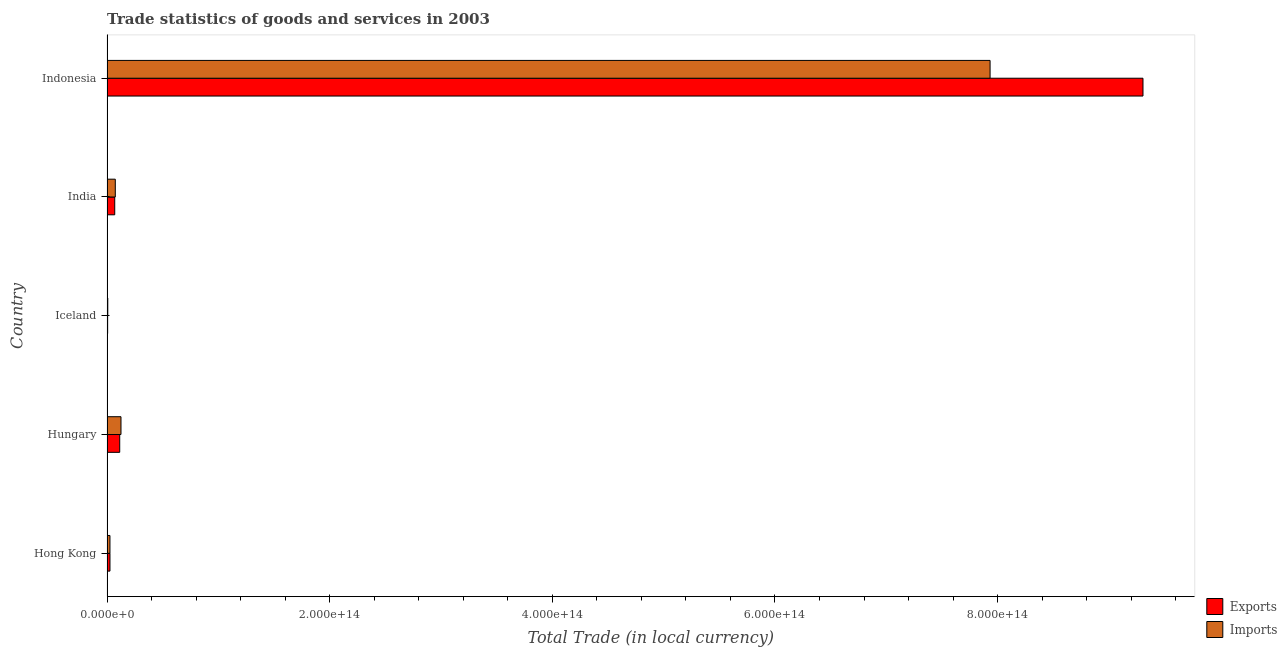How many different coloured bars are there?
Offer a very short reply. 2. Are the number of bars per tick equal to the number of legend labels?
Your response must be concise. Yes. How many bars are there on the 2nd tick from the top?
Ensure brevity in your answer.  2. How many bars are there on the 4th tick from the bottom?
Offer a very short reply. 2. What is the label of the 3rd group of bars from the top?
Provide a succinct answer. Iceland. What is the imports of goods and services in Hong Kong?
Provide a succinct answer. 2.65e+12. Across all countries, what is the maximum export of goods and services?
Offer a terse response. 9.31e+14. Across all countries, what is the minimum export of goods and services?
Offer a very short reply. 5.66e+11. In which country was the imports of goods and services maximum?
Keep it short and to the point. Indonesia. In which country was the export of goods and services minimum?
Offer a very short reply. Iceland. What is the total imports of goods and services in the graph?
Your response must be concise. 8.17e+14. What is the difference between the export of goods and services in Hungary and that in India?
Your response must be concise. 4.48e+12. What is the difference between the imports of goods and services in Hong Kong and the export of goods and services in India?
Provide a succinct answer. -4.29e+12. What is the average imports of goods and services per country?
Offer a terse response. 1.63e+14. What is the difference between the imports of goods and services and export of goods and services in Hong Kong?
Provide a short and direct response. -8.14e+09. In how many countries, is the export of goods and services greater than 40000000000000 LCU?
Keep it short and to the point. 1. What is the ratio of the imports of goods and services in Hungary to that in Iceland?
Give a very brief answer. 18.11. Is the imports of goods and services in Hong Kong less than that in India?
Ensure brevity in your answer.  Yes. Is the difference between the export of goods and services in Hong Kong and Indonesia greater than the difference between the imports of goods and services in Hong Kong and Indonesia?
Make the answer very short. No. What is the difference between the highest and the second highest export of goods and services?
Your response must be concise. 9.19e+14. What is the difference between the highest and the lowest imports of goods and services?
Provide a succinct answer. 7.93e+14. In how many countries, is the imports of goods and services greater than the average imports of goods and services taken over all countries?
Keep it short and to the point. 1. What does the 1st bar from the top in Iceland represents?
Your answer should be compact. Imports. What does the 2nd bar from the bottom in India represents?
Make the answer very short. Imports. How many bars are there?
Your answer should be very brief. 10. Are all the bars in the graph horizontal?
Your answer should be compact. Yes. What is the difference between two consecutive major ticks on the X-axis?
Ensure brevity in your answer.  2.00e+14. Where does the legend appear in the graph?
Make the answer very short. Bottom right. What is the title of the graph?
Ensure brevity in your answer.  Trade statistics of goods and services in 2003. Does "Lowest 20% of population" appear as one of the legend labels in the graph?
Your answer should be compact. No. What is the label or title of the X-axis?
Give a very brief answer. Total Trade (in local currency). What is the Total Trade (in local currency) of Exports in Hong Kong?
Provide a short and direct response. 2.66e+12. What is the Total Trade (in local currency) of Imports in Hong Kong?
Offer a terse response. 2.65e+12. What is the Total Trade (in local currency) of Exports in Hungary?
Provide a succinct answer. 1.14e+13. What is the Total Trade (in local currency) in Imports in Hungary?
Ensure brevity in your answer.  1.26e+13. What is the Total Trade (in local currency) of Exports in Iceland?
Your answer should be very brief. 5.66e+11. What is the Total Trade (in local currency) in Imports in Iceland?
Offer a very short reply. 6.93e+11. What is the Total Trade (in local currency) of Exports in India?
Keep it short and to the point. 6.95e+12. What is the Total Trade (in local currency) of Imports in India?
Make the answer very short. 7.45e+12. What is the Total Trade (in local currency) of Exports in Indonesia?
Your answer should be very brief. 9.31e+14. What is the Total Trade (in local currency) in Imports in Indonesia?
Give a very brief answer. 7.93e+14. Across all countries, what is the maximum Total Trade (in local currency) of Exports?
Offer a terse response. 9.31e+14. Across all countries, what is the maximum Total Trade (in local currency) of Imports?
Make the answer very short. 7.93e+14. Across all countries, what is the minimum Total Trade (in local currency) in Exports?
Offer a terse response. 5.66e+11. Across all countries, what is the minimum Total Trade (in local currency) of Imports?
Your answer should be very brief. 6.93e+11. What is the total Total Trade (in local currency) of Exports in the graph?
Provide a short and direct response. 9.52e+14. What is the total Total Trade (in local currency) in Imports in the graph?
Provide a short and direct response. 8.17e+14. What is the difference between the Total Trade (in local currency) in Exports in Hong Kong and that in Hungary?
Provide a short and direct response. -8.77e+12. What is the difference between the Total Trade (in local currency) of Imports in Hong Kong and that in Hungary?
Offer a very short reply. -9.91e+12. What is the difference between the Total Trade (in local currency) of Exports in Hong Kong and that in Iceland?
Ensure brevity in your answer.  2.09e+12. What is the difference between the Total Trade (in local currency) in Imports in Hong Kong and that in Iceland?
Offer a terse response. 1.96e+12. What is the difference between the Total Trade (in local currency) of Exports in Hong Kong and that in India?
Ensure brevity in your answer.  -4.29e+12. What is the difference between the Total Trade (in local currency) in Imports in Hong Kong and that in India?
Ensure brevity in your answer.  -4.80e+12. What is the difference between the Total Trade (in local currency) in Exports in Hong Kong and that in Indonesia?
Make the answer very short. -9.28e+14. What is the difference between the Total Trade (in local currency) of Imports in Hong Kong and that in Indonesia?
Make the answer very short. -7.91e+14. What is the difference between the Total Trade (in local currency) in Exports in Hungary and that in Iceland?
Offer a very short reply. 1.09e+13. What is the difference between the Total Trade (in local currency) in Imports in Hungary and that in Iceland?
Make the answer very short. 1.19e+13. What is the difference between the Total Trade (in local currency) in Exports in Hungary and that in India?
Ensure brevity in your answer.  4.48e+12. What is the difference between the Total Trade (in local currency) of Imports in Hungary and that in India?
Provide a succinct answer. 5.11e+12. What is the difference between the Total Trade (in local currency) in Exports in Hungary and that in Indonesia?
Your response must be concise. -9.19e+14. What is the difference between the Total Trade (in local currency) in Imports in Hungary and that in Indonesia?
Give a very brief answer. -7.81e+14. What is the difference between the Total Trade (in local currency) in Exports in Iceland and that in India?
Provide a succinct answer. -6.38e+12. What is the difference between the Total Trade (in local currency) in Imports in Iceland and that in India?
Offer a terse response. -6.76e+12. What is the difference between the Total Trade (in local currency) of Exports in Iceland and that in Indonesia?
Give a very brief answer. -9.30e+14. What is the difference between the Total Trade (in local currency) of Imports in Iceland and that in Indonesia?
Your answer should be very brief. -7.93e+14. What is the difference between the Total Trade (in local currency) of Exports in India and that in Indonesia?
Your response must be concise. -9.24e+14. What is the difference between the Total Trade (in local currency) of Imports in India and that in Indonesia?
Offer a very short reply. -7.86e+14. What is the difference between the Total Trade (in local currency) in Exports in Hong Kong and the Total Trade (in local currency) in Imports in Hungary?
Your response must be concise. -9.90e+12. What is the difference between the Total Trade (in local currency) in Exports in Hong Kong and the Total Trade (in local currency) in Imports in Iceland?
Ensure brevity in your answer.  1.97e+12. What is the difference between the Total Trade (in local currency) in Exports in Hong Kong and the Total Trade (in local currency) in Imports in India?
Your answer should be very brief. -4.79e+12. What is the difference between the Total Trade (in local currency) of Exports in Hong Kong and the Total Trade (in local currency) of Imports in Indonesia?
Offer a very short reply. -7.91e+14. What is the difference between the Total Trade (in local currency) in Exports in Hungary and the Total Trade (in local currency) in Imports in Iceland?
Provide a short and direct response. 1.07e+13. What is the difference between the Total Trade (in local currency) of Exports in Hungary and the Total Trade (in local currency) of Imports in India?
Keep it short and to the point. 3.98e+12. What is the difference between the Total Trade (in local currency) of Exports in Hungary and the Total Trade (in local currency) of Imports in Indonesia?
Offer a very short reply. -7.82e+14. What is the difference between the Total Trade (in local currency) in Exports in Iceland and the Total Trade (in local currency) in Imports in India?
Provide a short and direct response. -6.88e+12. What is the difference between the Total Trade (in local currency) in Exports in Iceland and the Total Trade (in local currency) in Imports in Indonesia?
Provide a succinct answer. -7.93e+14. What is the difference between the Total Trade (in local currency) in Exports in India and the Total Trade (in local currency) in Imports in Indonesia?
Give a very brief answer. -7.86e+14. What is the average Total Trade (in local currency) of Exports per country?
Offer a terse response. 1.90e+14. What is the average Total Trade (in local currency) in Imports per country?
Your answer should be compact. 1.63e+14. What is the difference between the Total Trade (in local currency) in Exports and Total Trade (in local currency) in Imports in Hong Kong?
Offer a very short reply. 8.14e+09. What is the difference between the Total Trade (in local currency) in Exports and Total Trade (in local currency) in Imports in Hungary?
Your answer should be compact. -1.14e+12. What is the difference between the Total Trade (in local currency) of Exports and Total Trade (in local currency) of Imports in Iceland?
Ensure brevity in your answer.  -1.28e+11. What is the difference between the Total Trade (in local currency) in Exports and Total Trade (in local currency) in Imports in India?
Your response must be concise. -5.04e+11. What is the difference between the Total Trade (in local currency) of Exports and Total Trade (in local currency) of Imports in Indonesia?
Your response must be concise. 1.37e+14. What is the ratio of the Total Trade (in local currency) in Exports in Hong Kong to that in Hungary?
Your answer should be compact. 0.23. What is the ratio of the Total Trade (in local currency) in Imports in Hong Kong to that in Hungary?
Your answer should be compact. 0.21. What is the ratio of the Total Trade (in local currency) of Exports in Hong Kong to that in Iceland?
Ensure brevity in your answer.  4.7. What is the ratio of the Total Trade (in local currency) in Imports in Hong Kong to that in Iceland?
Provide a short and direct response. 3.82. What is the ratio of the Total Trade (in local currency) of Exports in Hong Kong to that in India?
Make the answer very short. 0.38. What is the ratio of the Total Trade (in local currency) of Imports in Hong Kong to that in India?
Give a very brief answer. 0.36. What is the ratio of the Total Trade (in local currency) in Exports in Hong Kong to that in Indonesia?
Make the answer very short. 0. What is the ratio of the Total Trade (in local currency) in Imports in Hong Kong to that in Indonesia?
Provide a succinct answer. 0. What is the ratio of the Total Trade (in local currency) of Exports in Hungary to that in Iceland?
Offer a terse response. 20.2. What is the ratio of the Total Trade (in local currency) of Imports in Hungary to that in Iceland?
Ensure brevity in your answer.  18.12. What is the ratio of the Total Trade (in local currency) in Exports in Hungary to that in India?
Your answer should be compact. 1.65. What is the ratio of the Total Trade (in local currency) of Imports in Hungary to that in India?
Offer a terse response. 1.69. What is the ratio of the Total Trade (in local currency) in Exports in Hungary to that in Indonesia?
Give a very brief answer. 0.01. What is the ratio of the Total Trade (in local currency) in Imports in Hungary to that in Indonesia?
Your answer should be compact. 0.02. What is the ratio of the Total Trade (in local currency) in Exports in Iceland to that in India?
Provide a short and direct response. 0.08. What is the ratio of the Total Trade (in local currency) in Imports in Iceland to that in India?
Your answer should be very brief. 0.09. What is the ratio of the Total Trade (in local currency) in Exports in Iceland to that in Indonesia?
Your answer should be very brief. 0. What is the ratio of the Total Trade (in local currency) in Imports in Iceland to that in Indonesia?
Your answer should be very brief. 0. What is the ratio of the Total Trade (in local currency) in Exports in India to that in Indonesia?
Your answer should be very brief. 0.01. What is the ratio of the Total Trade (in local currency) in Imports in India to that in Indonesia?
Your answer should be very brief. 0.01. What is the difference between the highest and the second highest Total Trade (in local currency) in Exports?
Ensure brevity in your answer.  9.19e+14. What is the difference between the highest and the second highest Total Trade (in local currency) in Imports?
Your answer should be compact. 7.81e+14. What is the difference between the highest and the lowest Total Trade (in local currency) in Exports?
Offer a terse response. 9.30e+14. What is the difference between the highest and the lowest Total Trade (in local currency) in Imports?
Make the answer very short. 7.93e+14. 